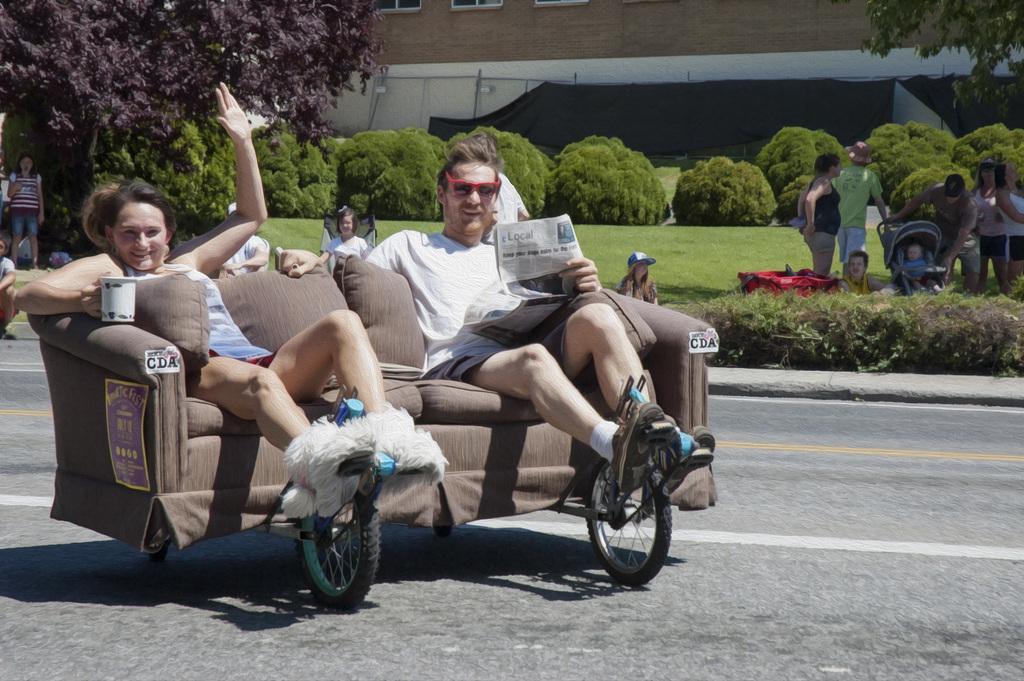Can you describe this image briefly? In this image there are two people sitting on the sofa. At the bottom of the image there is a road. On the right side of the image there are people standing on the grass. At the center of the image there are plants. In the background of the image there are trees and buildings. 